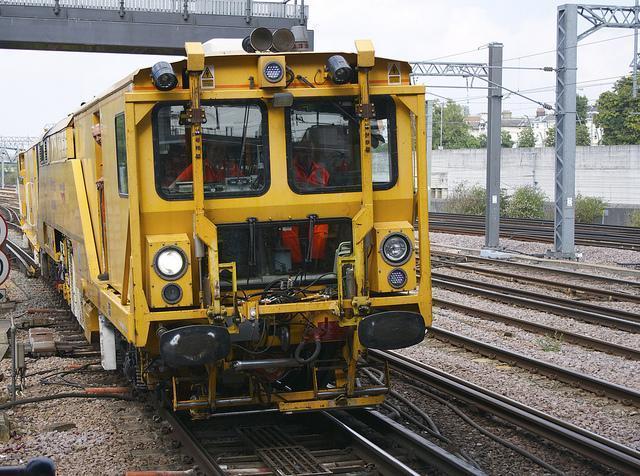How many white boats are to the side of the building?
Give a very brief answer. 0. 